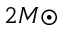<formula> <loc_0><loc_0><loc_500><loc_500>2 M { \odot }</formula> 